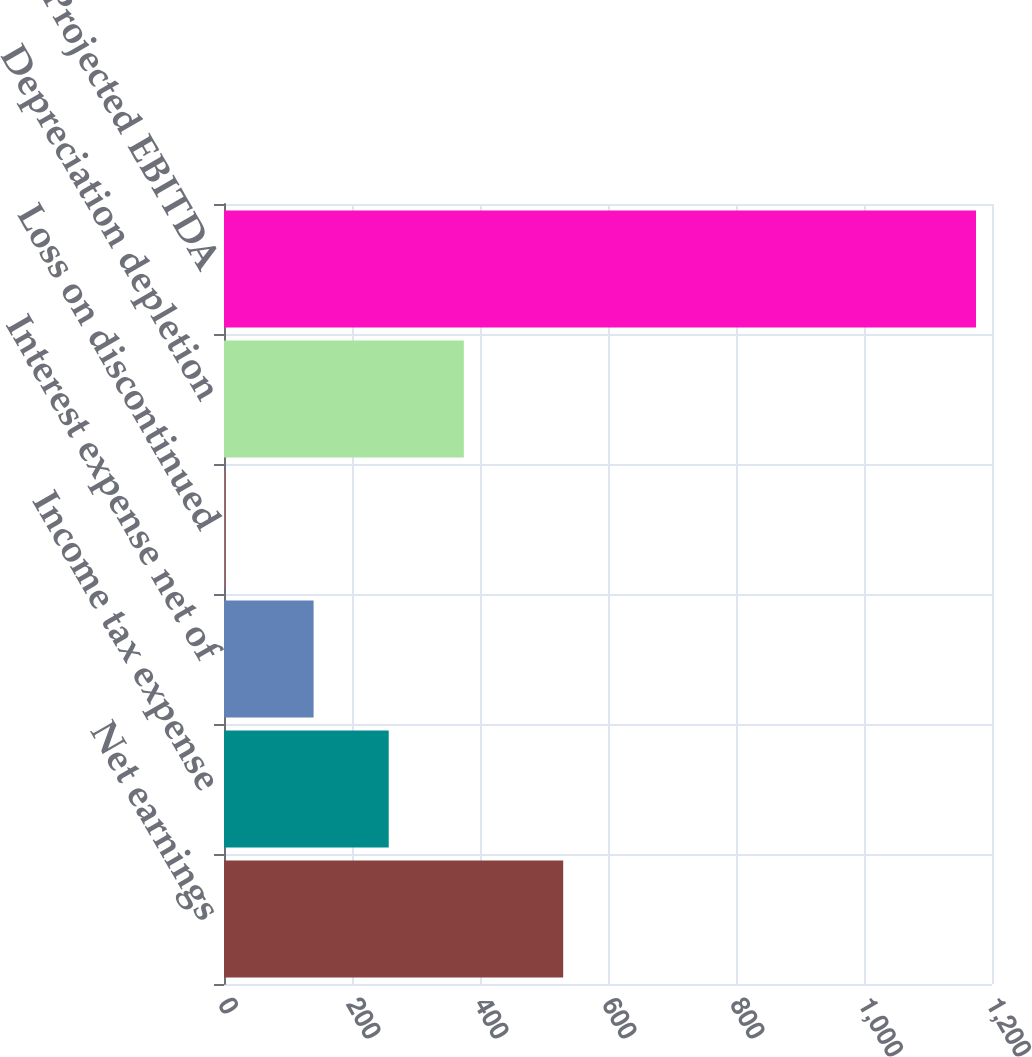<chart> <loc_0><loc_0><loc_500><loc_500><bar_chart><fcel>Net earnings<fcel>Income tax expense<fcel>Interest expense net of<fcel>Loss on discontinued<fcel>Depreciation depletion<fcel>Projected EBITDA<nl><fcel>530<fcel>257.38<fcel>140<fcel>1.24<fcel>374.76<fcel>1175<nl></chart> 